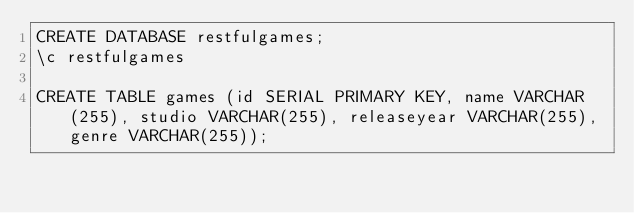Convert code to text. <code><loc_0><loc_0><loc_500><loc_500><_SQL_>CREATE DATABASE restfulgames;
\c restfulgames

CREATE TABLE games (id SERIAL PRIMARY KEY, name VARCHAR(255), studio VARCHAR(255), releaseyear VARCHAR(255), genre VARCHAR(255));
</code> 